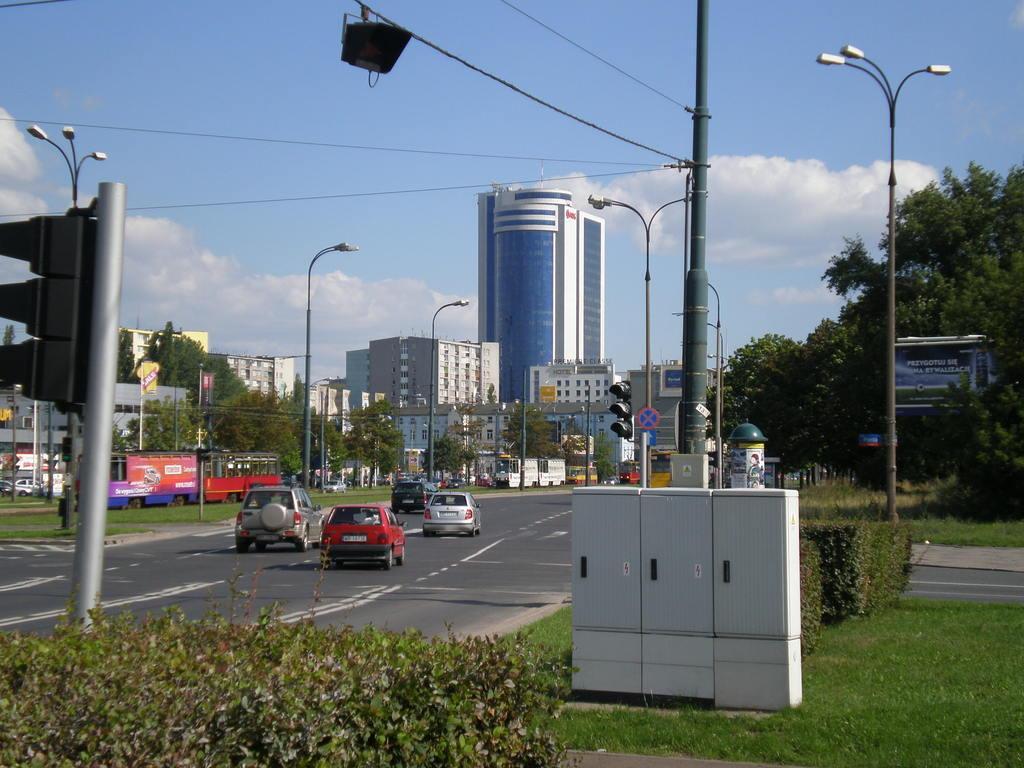Could you give a brief overview of what you see in this image? In this image there are vehicles on the road. There are street lights on the grassland having plants. Bottom of the image there is an object. Behind there is a pole connected with the wires. There is a board attached to the pole. There is a traffic light. Background there are trees and buildings. Right side there is a board having some text. Top of the image there is sky with some clouds. 